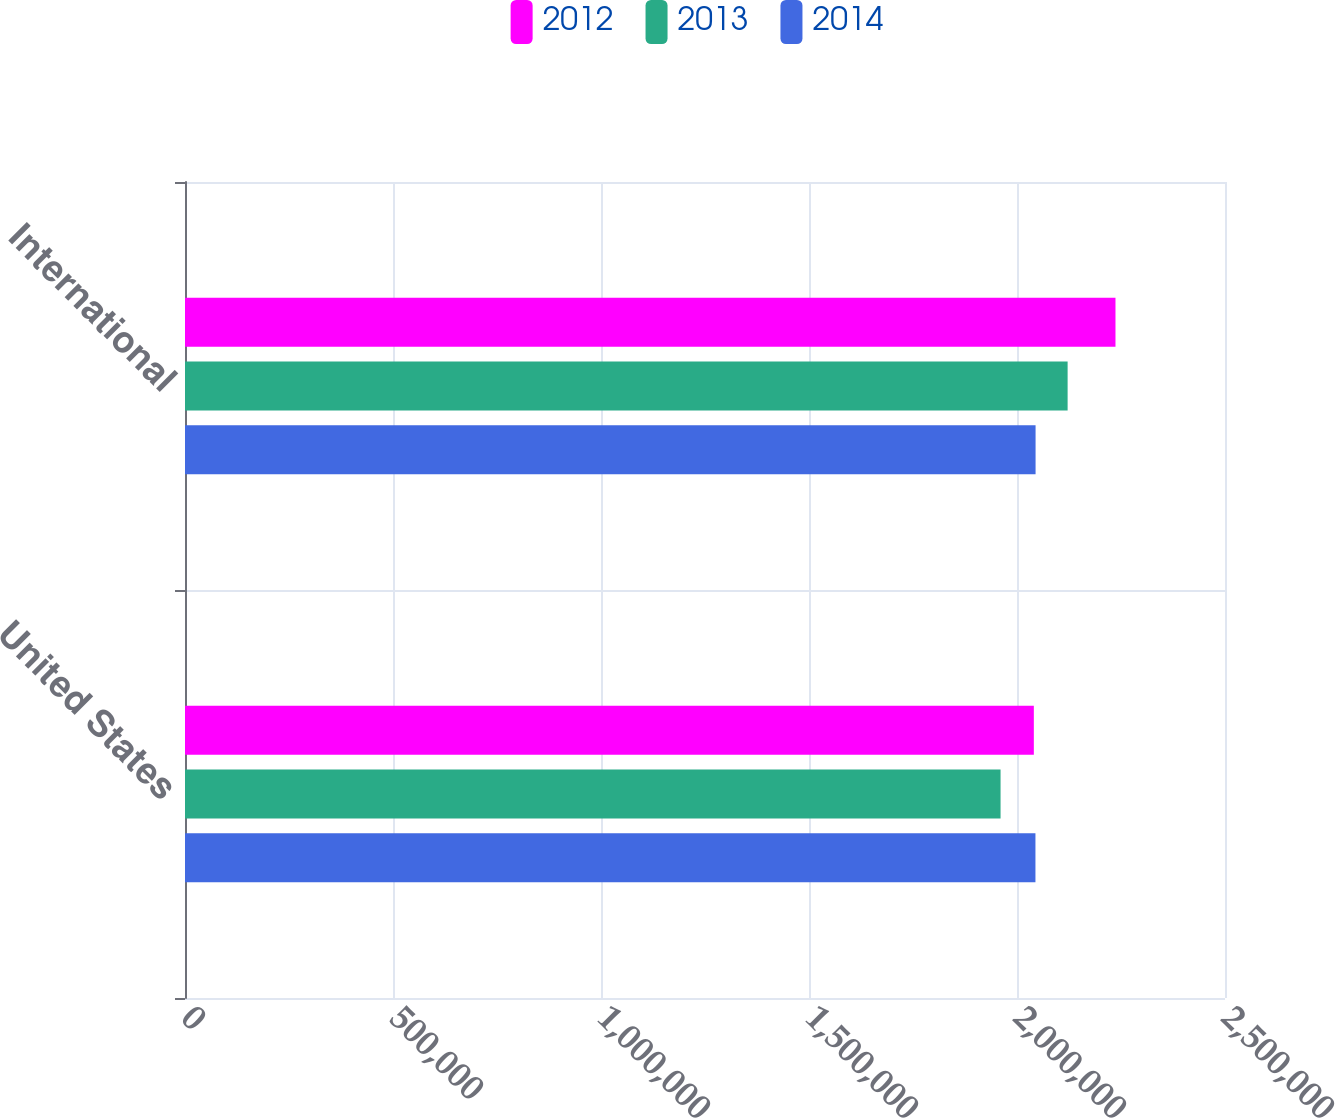Convert chart to OTSL. <chart><loc_0><loc_0><loc_500><loc_500><stacked_bar_chart><ecel><fcel>United States<fcel>International<nl><fcel>2012<fcel>2.04048e+06<fcel>2.23673e+06<nl><fcel>2013<fcel>1.96048e+06<fcel>2.12168e+06<nl><fcel>2014<fcel>2.04434e+06<fcel>2.04464e+06<nl></chart> 